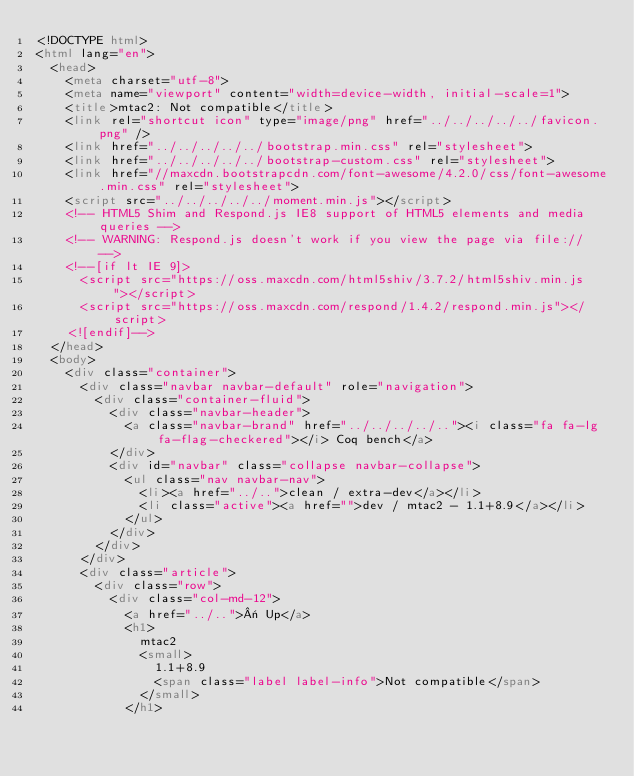<code> <loc_0><loc_0><loc_500><loc_500><_HTML_><!DOCTYPE html>
<html lang="en">
  <head>
    <meta charset="utf-8">
    <meta name="viewport" content="width=device-width, initial-scale=1">
    <title>mtac2: Not compatible</title>
    <link rel="shortcut icon" type="image/png" href="../../../../../favicon.png" />
    <link href="../../../../../bootstrap.min.css" rel="stylesheet">
    <link href="../../../../../bootstrap-custom.css" rel="stylesheet">
    <link href="//maxcdn.bootstrapcdn.com/font-awesome/4.2.0/css/font-awesome.min.css" rel="stylesheet">
    <script src="../../../../../moment.min.js"></script>
    <!-- HTML5 Shim and Respond.js IE8 support of HTML5 elements and media queries -->
    <!-- WARNING: Respond.js doesn't work if you view the page via file:// -->
    <!--[if lt IE 9]>
      <script src="https://oss.maxcdn.com/html5shiv/3.7.2/html5shiv.min.js"></script>
      <script src="https://oss.maxcdn.com/respond/1.4.2/respond.min.js"></script>
    <![endif]-->
  </head>
  <body>
    <div class="container">
      <div class="navbar navbar-default" role="navigation">
        <div class="container-fluid">
          <div class="navbar-header">
            <a class="navbar-brand" href="../../../../.."><i class="fa fa-lg fa-flag-checkered"></i> Coq bench</a>
          </div>
          <div id="navbar" class="collapse navbar-collapse">
            <ul class="nav navbar-nav">
              <li><a href="../..">clean / extra-dev</a></li>
              <li class="active"><a href="">dev / mtac2 - 1.1+8.9</a></li>
            </ul>
          </div>
        </div>
      </div>
      <div class="article">
        <div class="row">
          <div class="col-md-12">
            <a href="../..">« Up</a>
            <h1>
              mtac2
              <small>
                1.1+8.9
                <span class="label label-info">Not compatible</span>
              </small>
            </h1></code> 